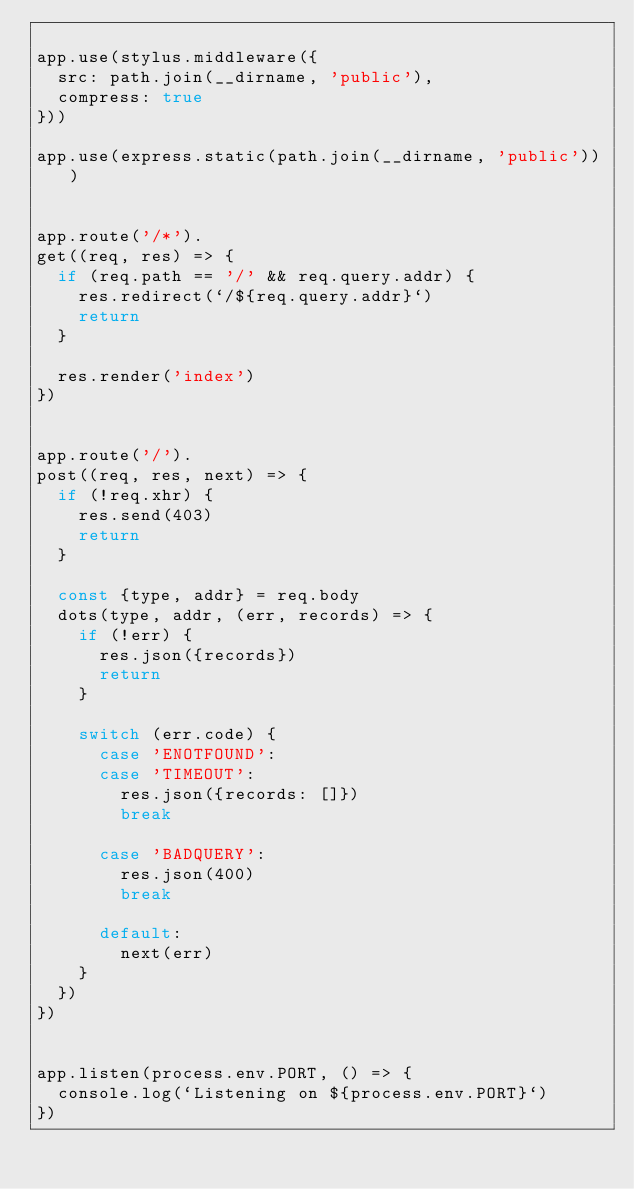Convert code to text. <code><loc_0><loc_0><loc_500><loc_500><_JavaScript_>
app.use(stylus.middleware({
  src: path.join(__dirname, 'public'),
  compress: true
}))

app.use(express.static(path.join(__dirname, 'public')))


app.route('/*').
get((req, res) => {
  if (req.path == '/' && req.query.addr) {
    res.redirect(`/${req.query.addr}`)
    return
  }

  res.render('index')
})


app.route('/').
post((req, res, next) => {
  if (!req.xhr) {
    res.send(403)
    return
  }

  const {type, addr} = req.body
  dots(type, addr, (err, records) => {
    if (!err) {
      res.json({records})
      return
    }

    switch (err.code) {
      case 'ENOTFOUND':
      case 'TIMEOUT':
        res.json({records: []})
        break

      case 'BADQUERY':
        res.json(400)
        break

      default:
        next(err)
    }
  })
})


app.listen(process.env.PORT, () => {
  console.log(`Listening on ${process.env.PORT}`)
})
</code> 